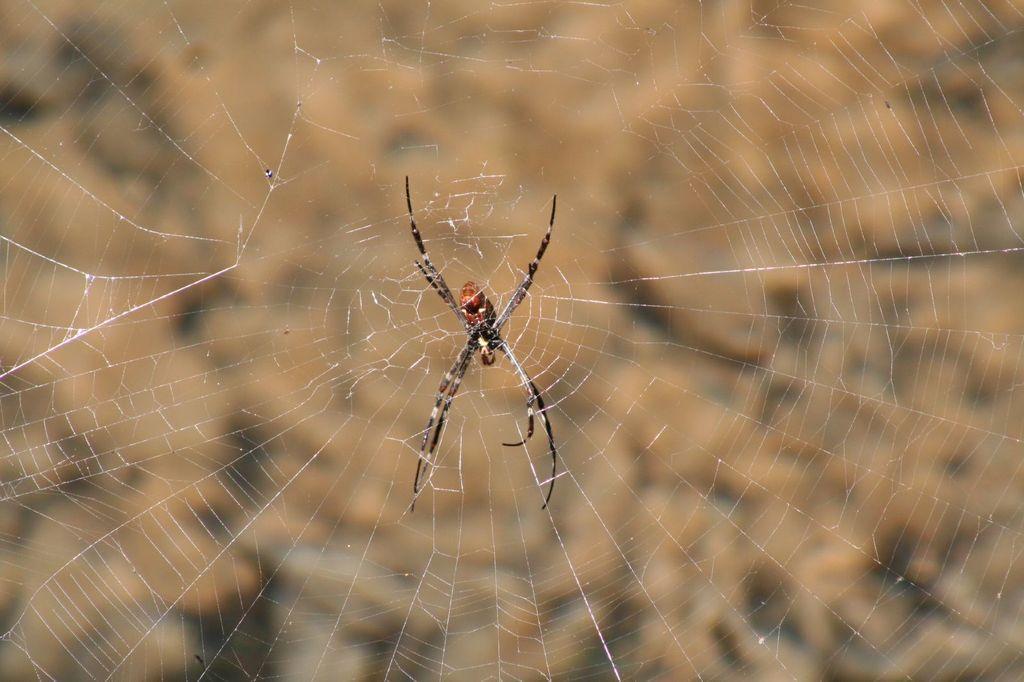In one or two sentences, can you explain what this image depicts? In this picture we can see a spider and web in the front, there is a blurry background. 